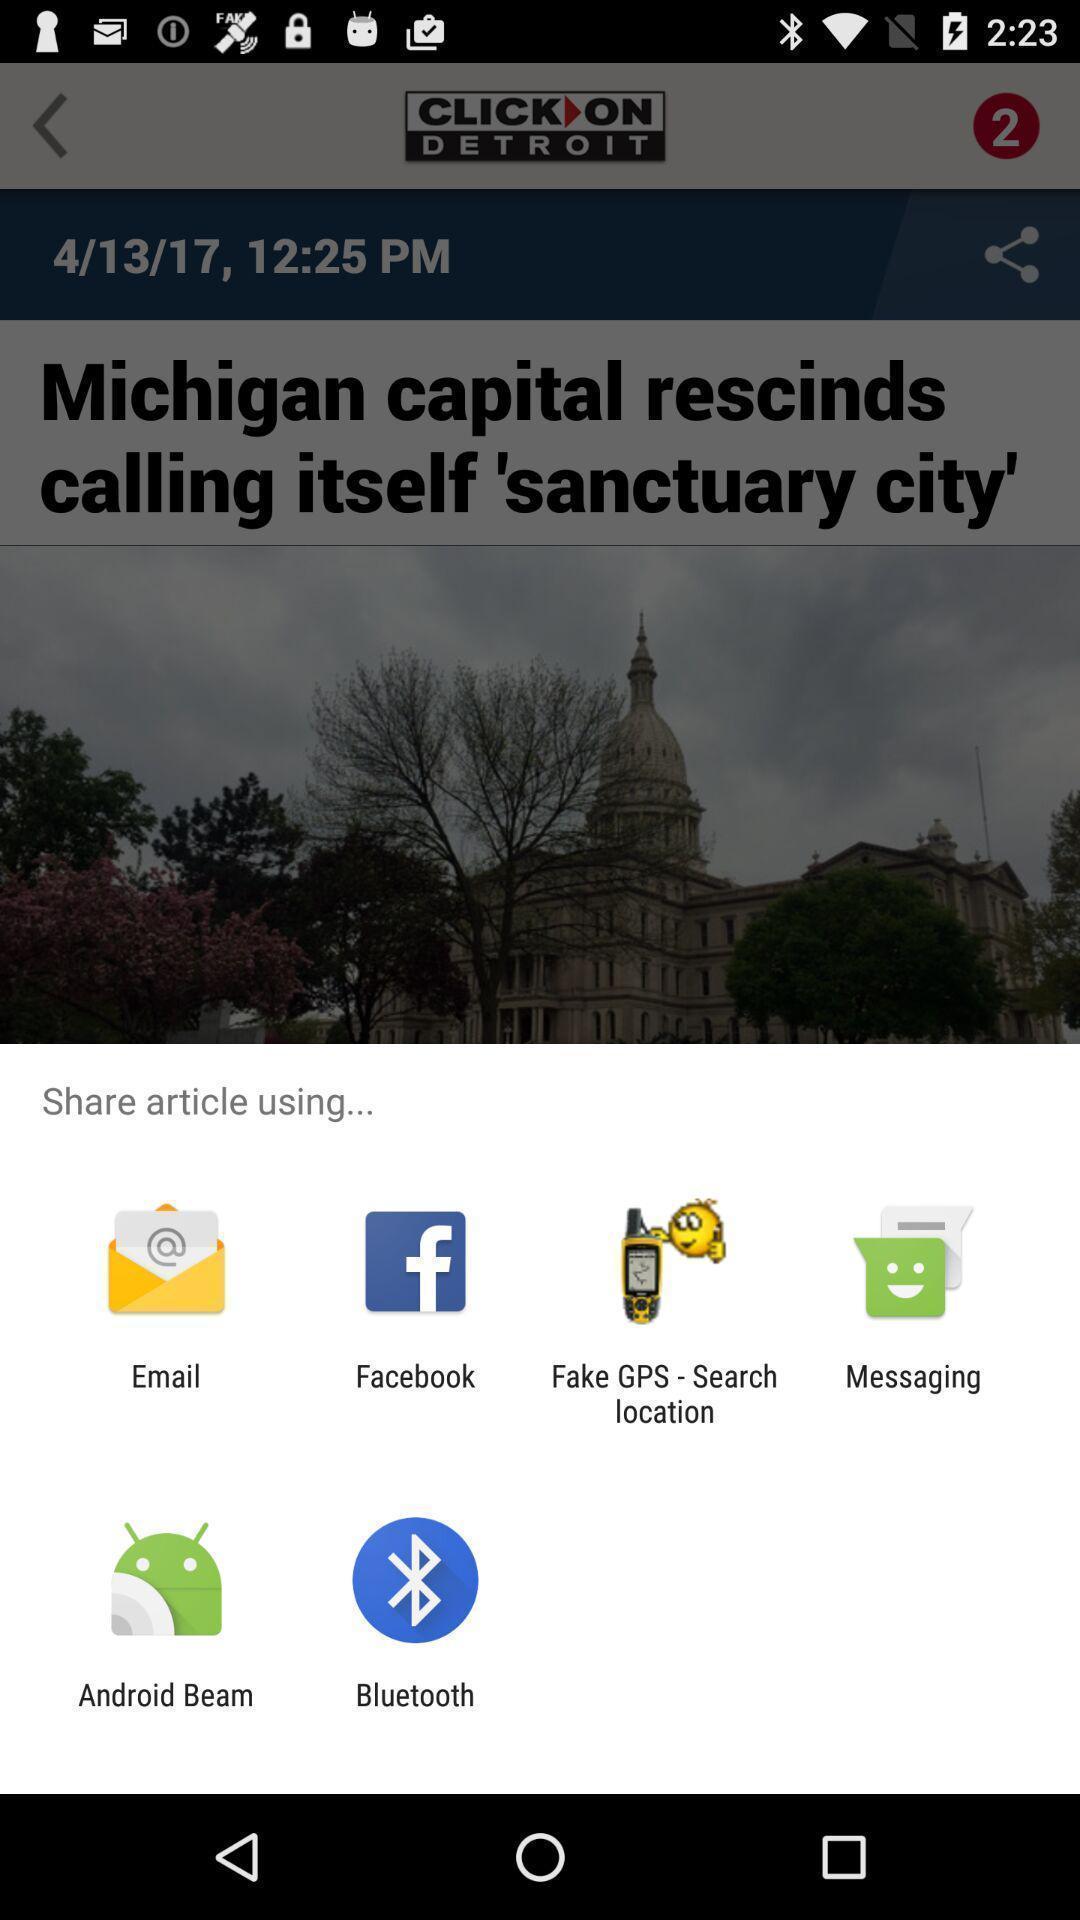Tell me what you see in this picture. Popup to share an article in the news application. 